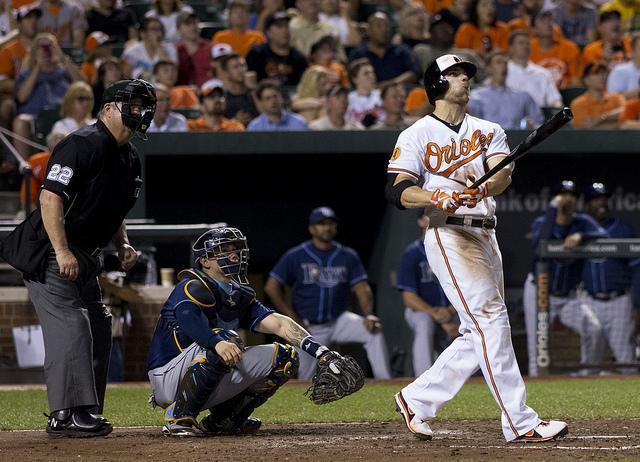How many people can be seen?
Give a very brief answer. 10. 